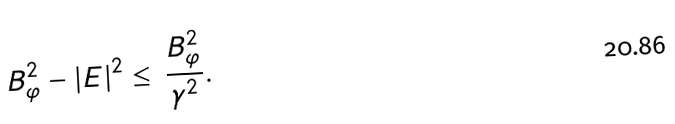<formula> <loc_0><loc_0><loc_500><loc_500>B _ { \varphi } ^ { 2 } - | { E } | ^ { 2 } \leq \, \frac { B _ { \varphi } ^ { 2 } } { \gamma ^ { 2 } } .</formula> 